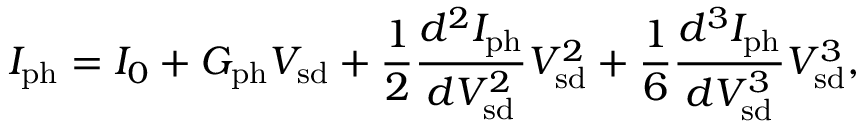Convert formula to latex. <formula><loc_0><loc_0><loc_500><loc_500>I _ { p h } = I _ { 0 } + G _ { p h } V _ { s d } + \frac { 1 } { 2 } \frac { d ^ { 2 } I _ { p h } } { d V _ { s d } ^ { 2 } } V _ { s d } ^ { 2 } + \frac { 1 } { 6 } \frac { d ^ { 3 } I _ { p h } } { d V _ { s d } ^ { 3 } } V _ { s d } ^ { 3 } ,</formula> 